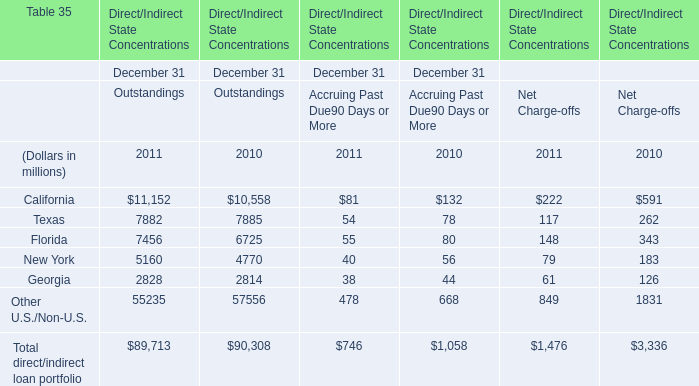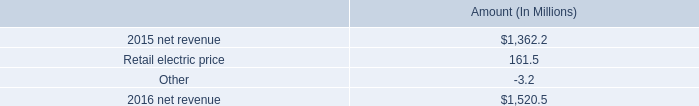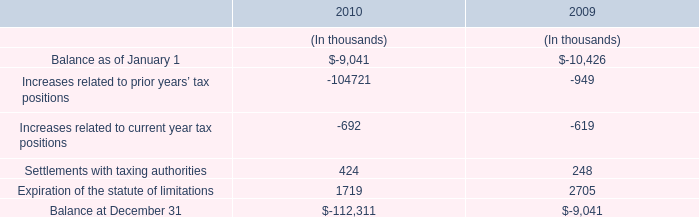what is the growth rate in net revenue in 2016 for entergy arkansas , inc.? 
Computations: ((1520.5 - 1362.2) / 1362.2)
Answer: 0.11621. 